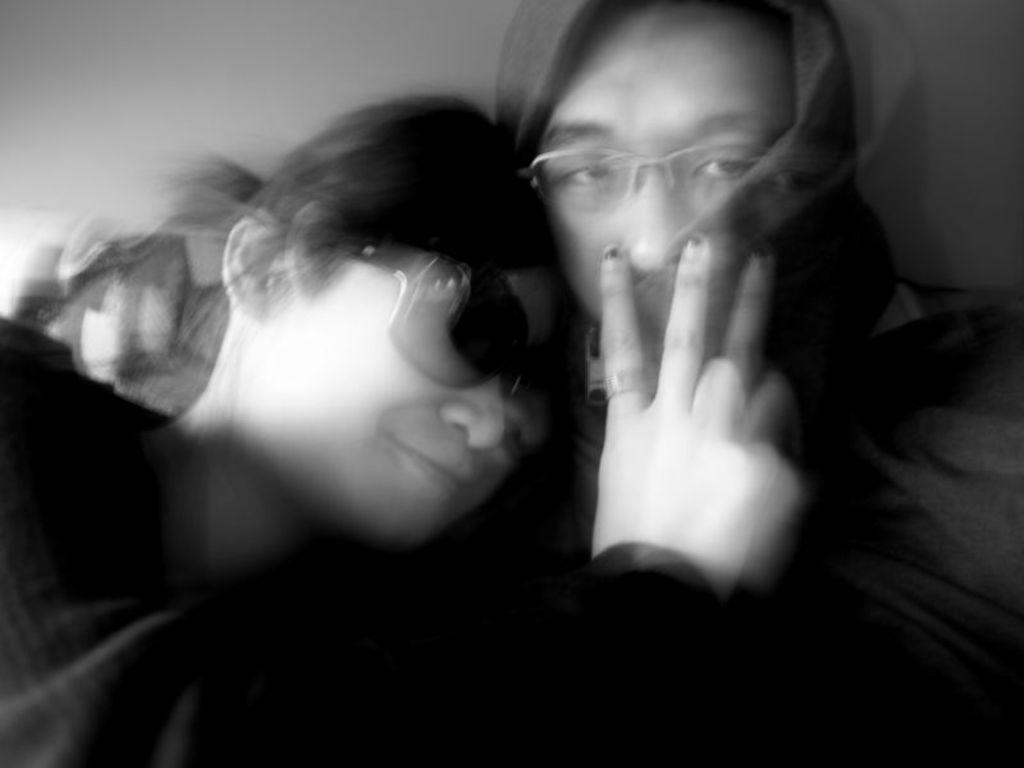What is the color scheme of the picture? The picture is in black and white. How many people are in the image? There are two persons in the picture. What type of knowledge can be gained from the patch on the person's shirt in the image? There is no patch visible on any person's shirt in the image, and therefore no such knowledge can be gained. 